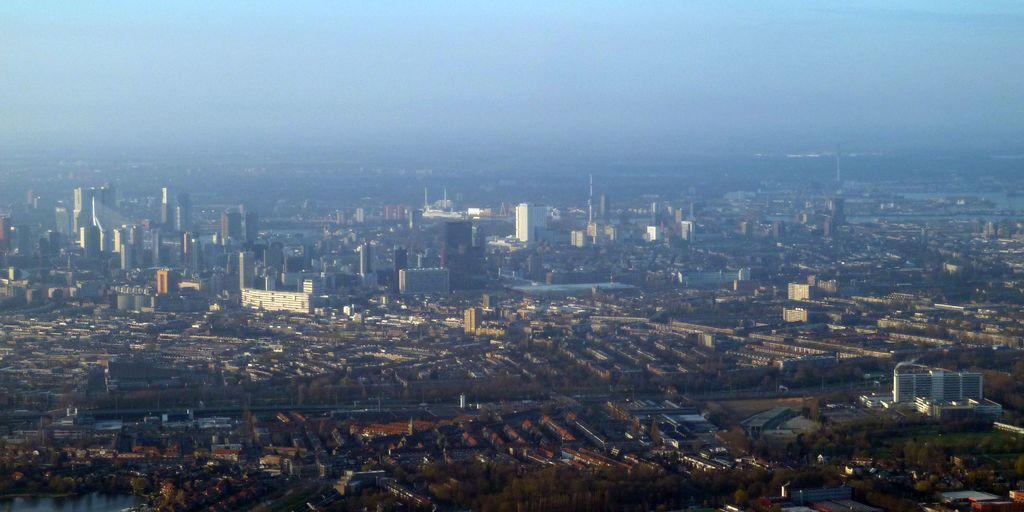Please provide a concise description of this image. Sky is in blue color. Here we can see buildings and trees. 